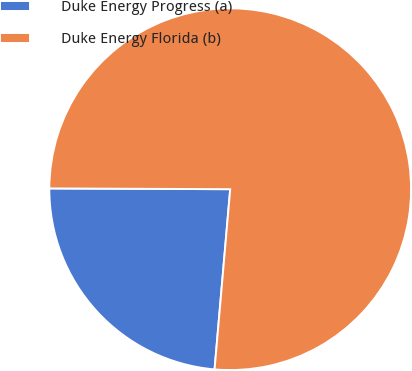<chart> <loc_0><loc_0><loc_500><loc_500><pie_chart><fcel>Duke Energy Progress (a)<fcel>Duke Energy Florida (b)<nl><fcel>23.69%<fcel>76.31%<nl></chart> 